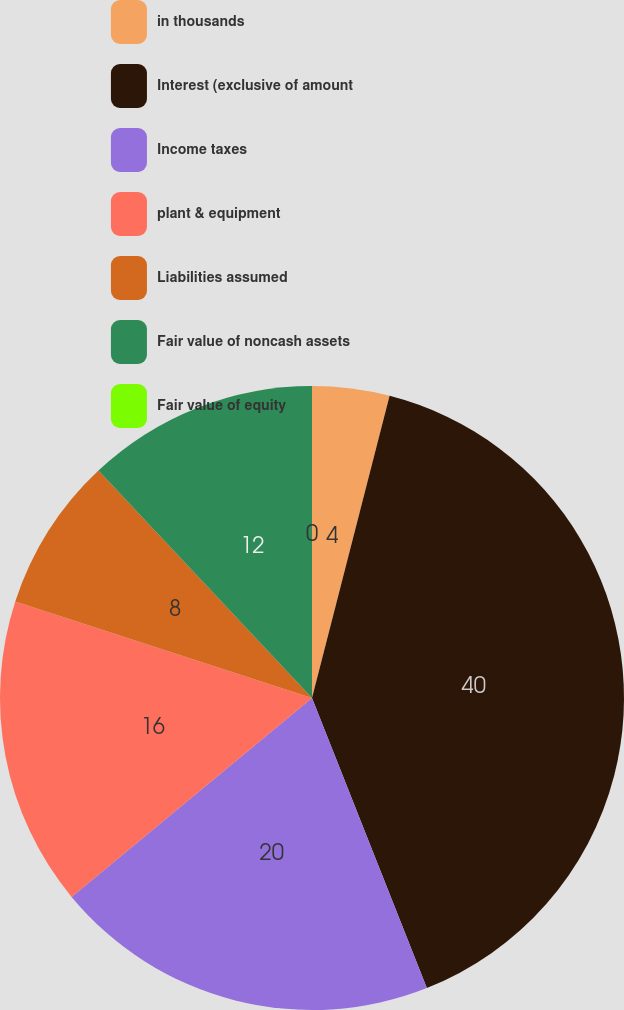Convert chart. <chart><loc_0><loc_0><loc_500><loc_500><pie_chart><fcel>in thousands<fcel>Interest (exclusive of amount<fcel>Income taxes<fcel>plant & equipment<fcel>Liabilities assumed<fcel>Fair value of noncash assets<fcel>Fair value of equity<nl><fcel>4.0%<fcel>40.0%<fcel>20.0%<fcel>16.0%<fcel>8.0%<fcel>12.0%<fcel>0.0%<nl></chart> 